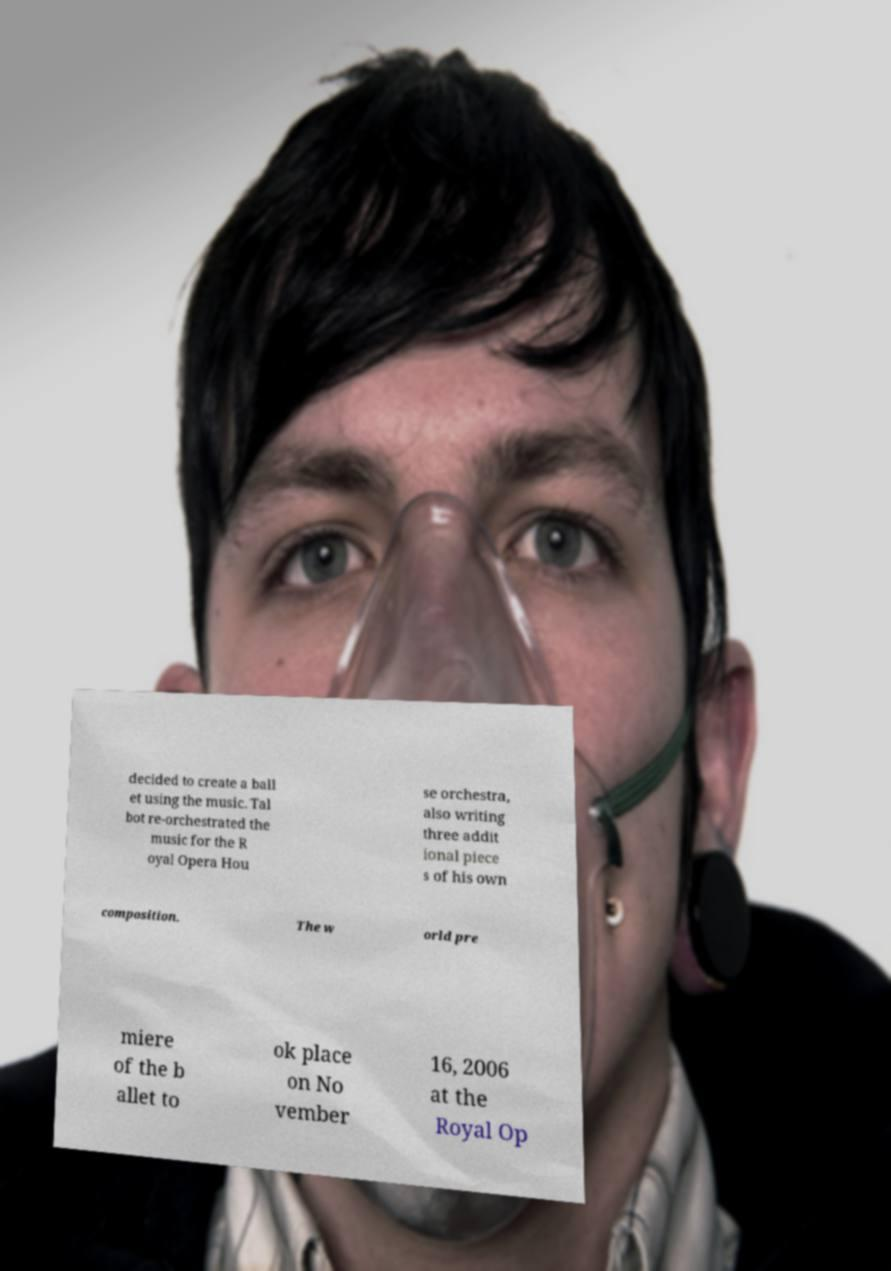Can you read and provide the text displayed in the image?This photo seems to have some interesting text. Can you extract and type it out for me? decided to create a ball et using the music. Tal bot re-orchestrated the music for the R oyal Opera Hou se orchestra, also writing three addit ional piece s of his own composition. The w orld pre miere of the b allet to ok place on No vember 16, 2006 at the Royal Op 